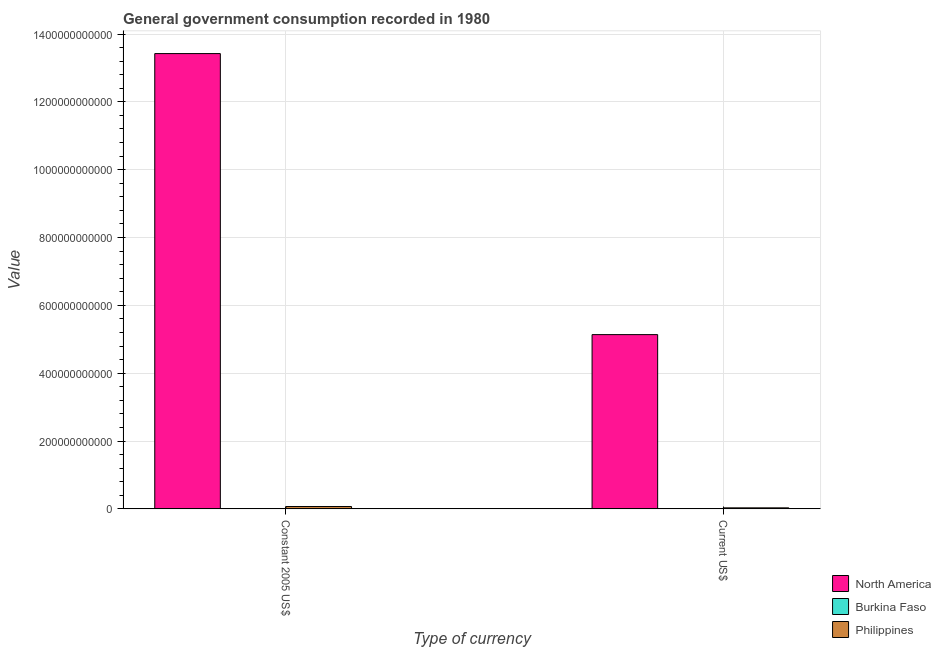How many different coloured bars are there?
Your response must be concise. 3. How many groups of bars are there?
Offer a very short reply. 2. Are the number of bars per tick equal to the number of legend labels?
Keep it short and to the point. Yes. How many bars are there on the 1st tick from the left?
Your response must be concise. 3. What is the label of the 2nd group of bars from the left?
Give a very brief answer. Current US$. What is the value consumed in current us$ in Burkina Faso?
Provide a short and direct response. 1.78e+08. Across all countries, what is the maximum value consumed in current us$?
Provide a short and direct response. 5.14e+11. Across all countries, what is the minimum value consumed in current us$?
Make the answer very short. 1.78e+08. In which country was the value consumed in current us$ maximum?
Offer a terse response. North America. In which country was the value consumed in current us$ minimum?
Give a very brief answer. Burkina Faso. What is the total value consumed in constant 2005 us$ in the graph?
Your answer should be very brief. 1.35e+12. What is the difference between the value consumed in current us$ in Philippines and that in North America?
Your answer should be very brief. -5.11e+11. What is the difference between the value consumed in current us$ in Philippines and the value consumed in constant 2005 us$ in Burkina Faso?
Ensure brevity in your answer.  2.63e+09. What is the average value consumed in constant 2005 us$ per country?
Offer a very short reply. 4.50e+11. What is the difference between the value consumed in constant 2005 us$ and value consumed in current us$ in Burkina Faso?
Ensure brevity in your answer.  1.37e+08. In how many countries, is the value consumed in constant 2005 us$ greater than 920000000000 ?
Ensure brevity in your answer.  1. What is the ratio of the value consumed in constant 2005 us$ in Philippines to that in Burkina Faso?
Provide a short and direct response. 21.69. Is the value consumed in constant 2005 us$ in Philippines less than that in North America?
Ensure brevity in your answer.  Yes. What does the 1st bar from the left in Current US$ represents?
Keep it short and to the point. North America. What does the 3rd bar from the right in Constant 2005 US$ represents?
Make the answer very short. North America. Are all the bars in the graph horizontal?
Make the answer very short. No. How many countries are there in the graph?
Give a very brief answer. 3. What is the difference between two consecutive major ticks on the Y-axis?
Make the answer very short. 2.00e+11. Are the values on the major ticks of Y-axis written in scientific E-notation?
Your answer should be compact. No. Does the graph contain grids?
Provide a succinct answer. Yes. How many legend labels are there?
Your answer should be very brief. 3. How are the legend labels stacked?
Ensure brevity in your answer.  Vertical. What is the title of the graph?
Provide a succinct answer. General government consumption recorded in 1980. Does "American Samoa" appear as one of the legend labels in the graph?
Ensure brevity in your answer.  No. What is the label or title of the X-axis?
Provide a short and direct response. Type of currency. What is the label or title of the Y-axis?
Provide a short and direct response. Value. What is the Value of North America in Constant 2005 US$?
Offer a terse response. 1.34e+12. What is the Value of Burkina Faso in Constant 2005 US$?
Your response must be concise. 3.15e+08. What is the Value in Philippines in Constant 2005 US$?
Your answer should be compact. 6.84e+09. What is the Value in North America in Current US$?
Your response must be concise. 5.14e+11. What is the Value in Burkina Faso in Current US$?
Offer a very short reply. 1.78e+08. What is the Value in Philippines in Current US$?
Make the answer very short. 2.94e+09. Across all Type of currency, what is the maximum Value in North America?
Offer a terse response. 1.34e+12. Across all Type of currency, what is the maximum Value in Burkina Faso?
Provide a succinct answer. 3.15e+08. Across all Type of currency, what is the maximum Value of Philippines?
Your response must be concise. 6.84e+09. Across all Type of currency, what is the minimum Value in North America?
Your answer should be very brief. 5.14e+11. Across all Type of currency, what is the minimum Value in Burkina Faso?
Offer a terse response. 1.78e+08. Across all Type of currency, what is the minimum Value of Philippines?
Your response must be concise. 2.94e+09. What is the total Value in North America in the graph?
Provide a short and direct response. 1.86e+12. What is the total Value of Burkina Faso in the graph?
Make the answer very short. 4.93e+08. What is the total Value of Philippines in the graph?
Your response must be concise. 9.78e+09. What is the difference between the Value of North America in Constant 2005 US$ and that in Current US$?
Make the answer very short. 8.29e+11. What is the difference between the Value in Burkina Faso in Constant 2005 US$ and that in Current US$?
Ensure brevity in your answer.  1.37e+08. What is the difference between the Value of Philippines in Constant 2005 US$ and that in Current US$?
Make the answer very short. 3.89e+09. What is the difference between the Value in North America in Constant 2005 US$ and the Value in Burkina Faso in Current US$?
Make the answer very short. 1.34e+12. What is the difference between the Value of North America in Constant 2005 US$ and the Value of Philippines in Current US$?
Offer a terse response. 1.34e+12. What is the difference between the Value of Burkina Faso in Constant 2005 US$ and the Value of Philippines in Current US$?
Give a very brief answer. -2.63e+09. What is the average Value in North America per Type of currency?
Offer a very short reply. 9.28e+11. What is the average Value in Burkina Faso per Type of currency?
Offer a terse response. 2.47e+08. What is the average Value of Philippines per Type of currency?
Offer a very short reply. 4.89e+09. What is the difference between the Value in North America and Value in Burkina Faso in Constant 2005 US$?
Your response must be concise. 1.34e+12. What is the difference between the Value in North America and Value in Philippines in Constant 2005 US$?
Provide a succinct answer. 1.34e+12. What is the difference between the Value of Burkina Faso and Value of Philippines in Constant 2005 US$?
Make the answer very short. -6.52e+09. What is the difference between the Value in North America and Value in Burkina Faso in Current US$?
Make the answer very short. 5.14e+11. What is the difference between the Value in North America and Value in Philippines in Current US$?
Give a very brief answer. 5.11e+11. What is the difference between the Value of Burkina Faso and Value of Philippines in Current US$?
Your answer should be compact. -2.76e+09. What is the ratio of the Value of North America in Constant 2005 US$ to that in Current US$?
Give a very brief answer. 2.61. What is the ratio of the Value in Burkina Faso in Constant 2005 US$ to that in Current US$?
Provide a short and direct response. 1.77. What is the ratio of the Value in Philippines in Constant 2005 US$ to that in Current US$?
Keep it short and to the point. 2.32. What is the difference between the highest and the second highest Value of North America?
Provide a short and direct response. 8.29e+11. What is the difference between the highest and the second highest Value of Burkina Faso?
Ensure brevity in your answer.  1.37e+08. What is the difference between the highest and the second highest Value in Philippines?
Offer a terse response. 3.89e+09. What is the difference between the highest and the lowest Value of North America?
Provide a short and direct response. 8.29e+11. What is the difference between the highest and the lowest Value of Burkina Faso?
Ensure brevity in your answer.  1.37e+08. What is the difference between the highest and the lowest Value of Philippines?
Your answer should be compact. 3.89e+09. 